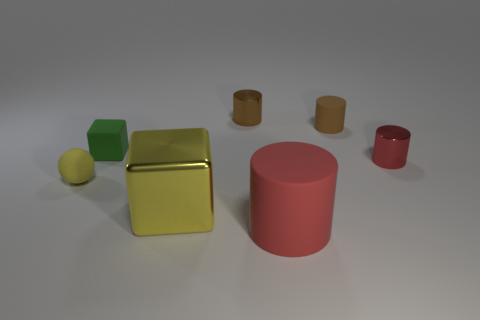What is the size of the red thing right of the matte thing in front of the matte ball?
Your response must be concise. Small. Are there an equal number of large matte cylinders on the left side of the red matte cylinder and big red things that are behind the brown metal cylinder?
Keep it short and to the point. Yes. Are there any tiny cylinders on the right side of the cube that is in front of the small matte cube?
Give a very brief answer. Yes. What is the shape of the brown thing that is made of the same material as the green object?
Your answer should be very brief. Cylinder. Is there any other thing of the same color as the small block?
Keep it short and to the point. No. There is a red cylinder behind the thing that is on the left side of the green cube; what is its material?
Your response must be concise. Metal. Are there any small brown objects of the same shape as the tiny green object?
Make the answer very short. No. What number of other things are the same shape as the large red rubber thing?
Provide a succinct answer. 3. There is a metallic thing that is both behind the yellow metallic cube and left of the big red thing; what is its shape?
Your response must be concise. Cylinder. There is a matte object right of the large cylinder; what size is it?
Offer a very short reply. Small. 